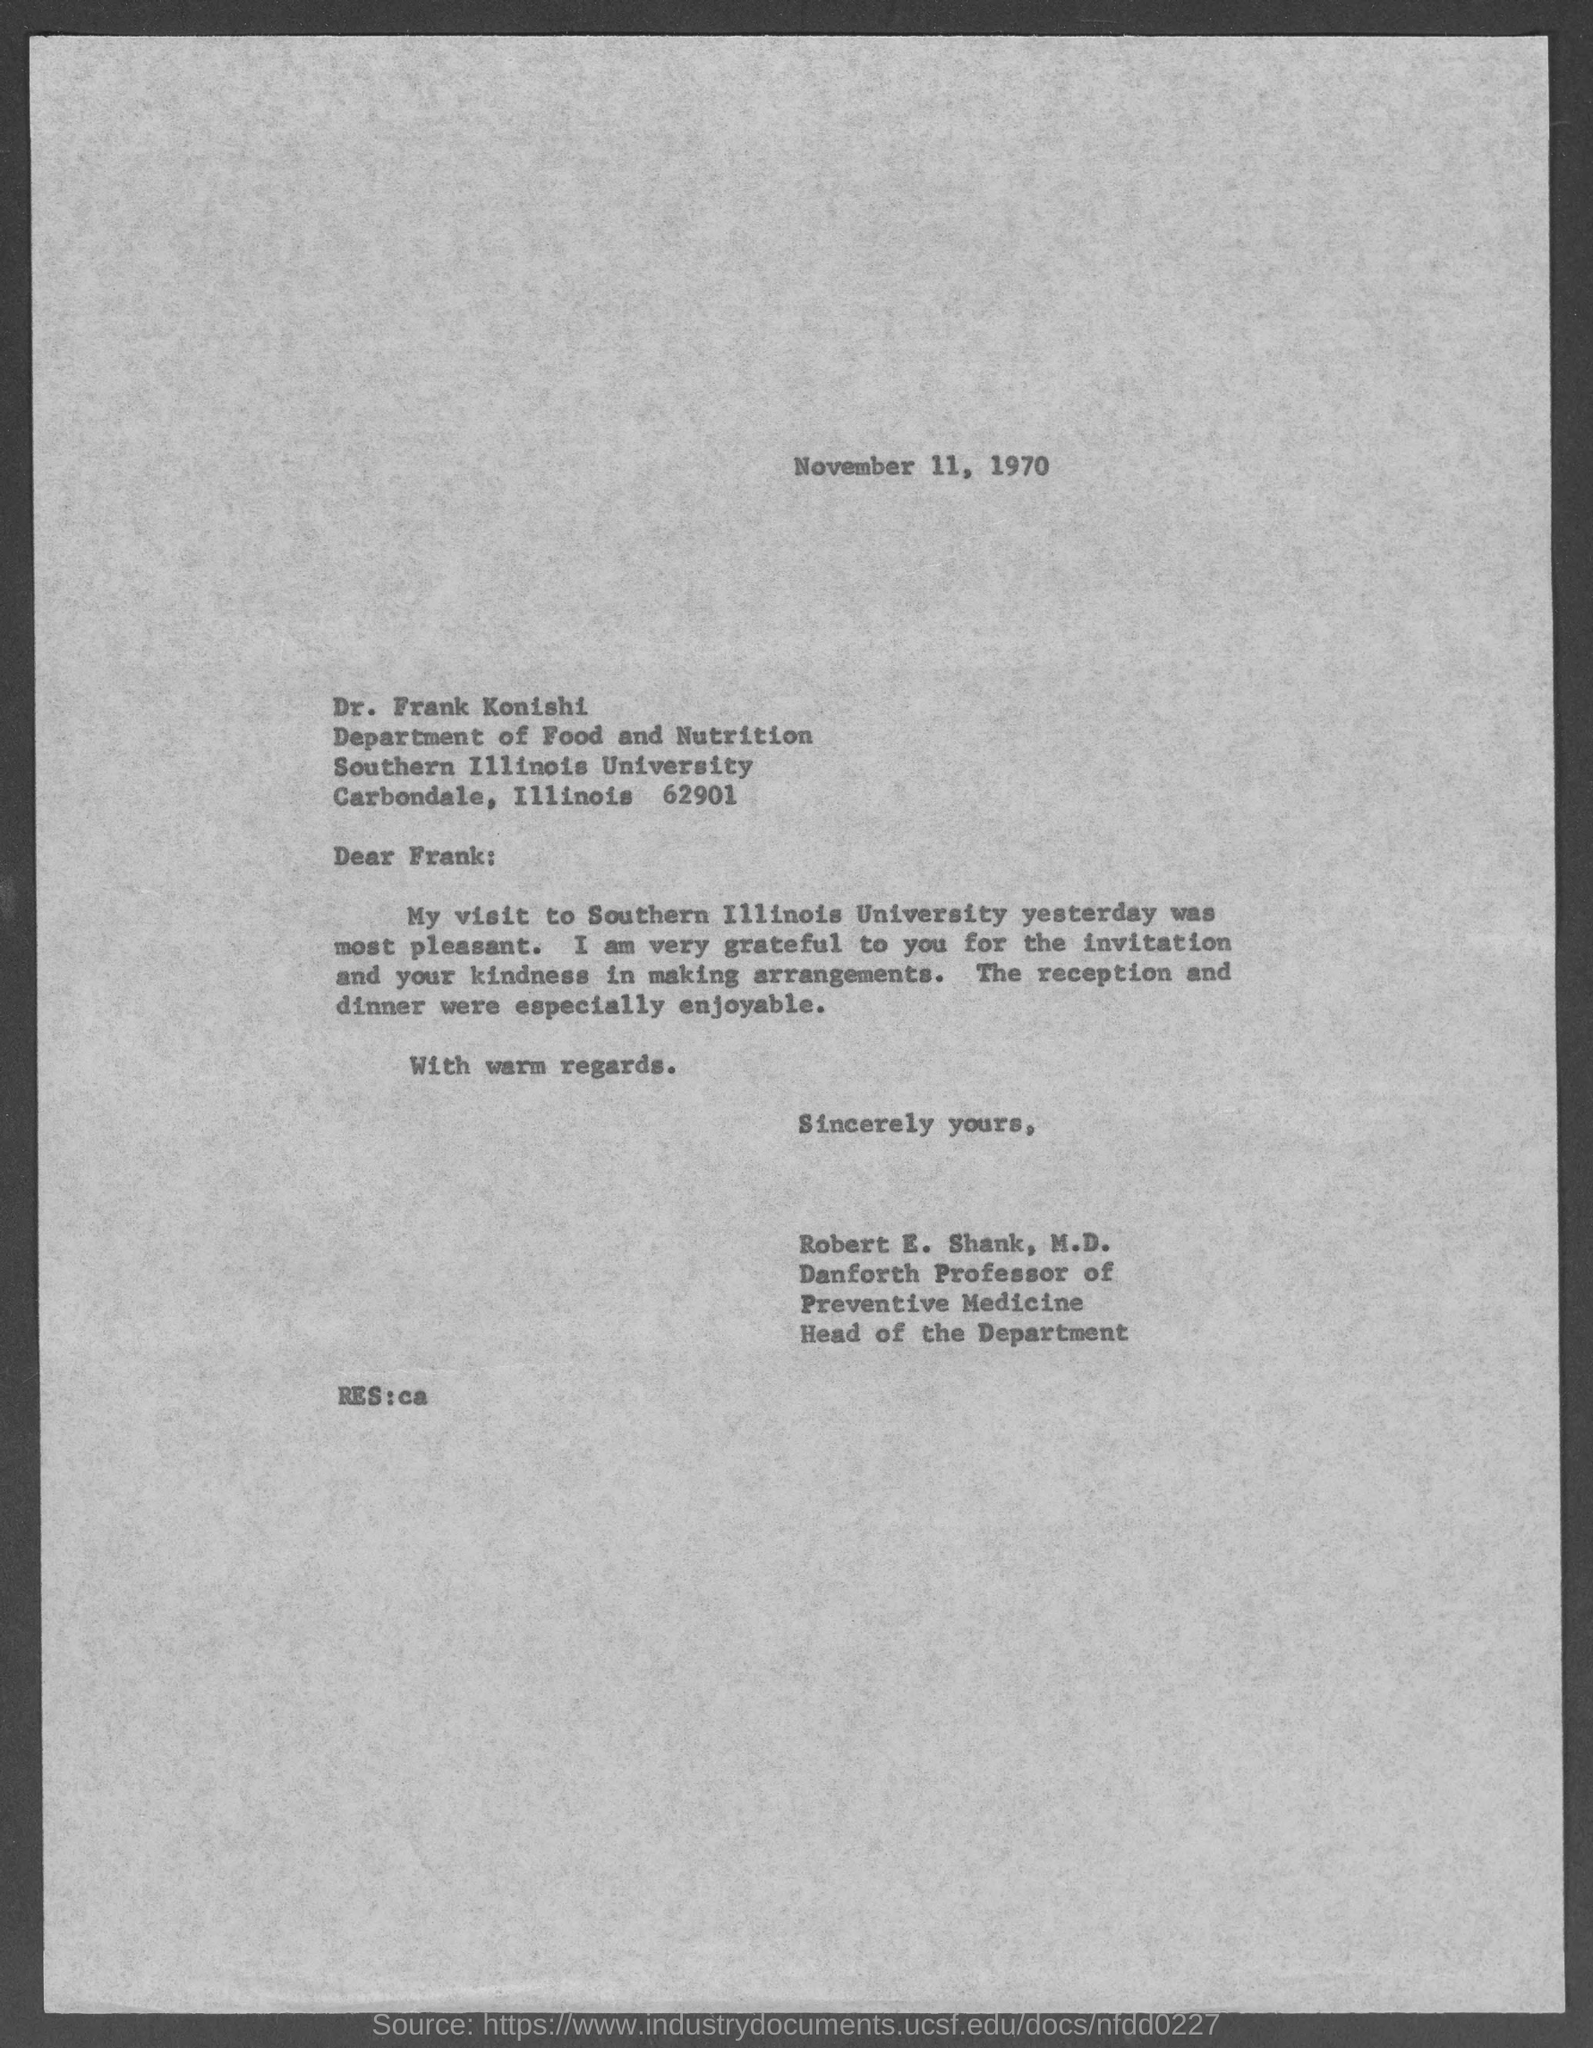What is the date mentioned in document?
Ensure brevity in your answer.  November 11, 1970. To whom this letter is written to?
Your answer should be compact. Dr. Frank Konishi. What is the postal address of southern illinois university?
Keep it short and to the point. Carbondale, Illinois 62901. Who wrote this letter?
Keep it short and to the point. Robert E. Shank, M.D. Who is head of the department ?
Give a very brief answer. Robert E. Shank, M.D. 